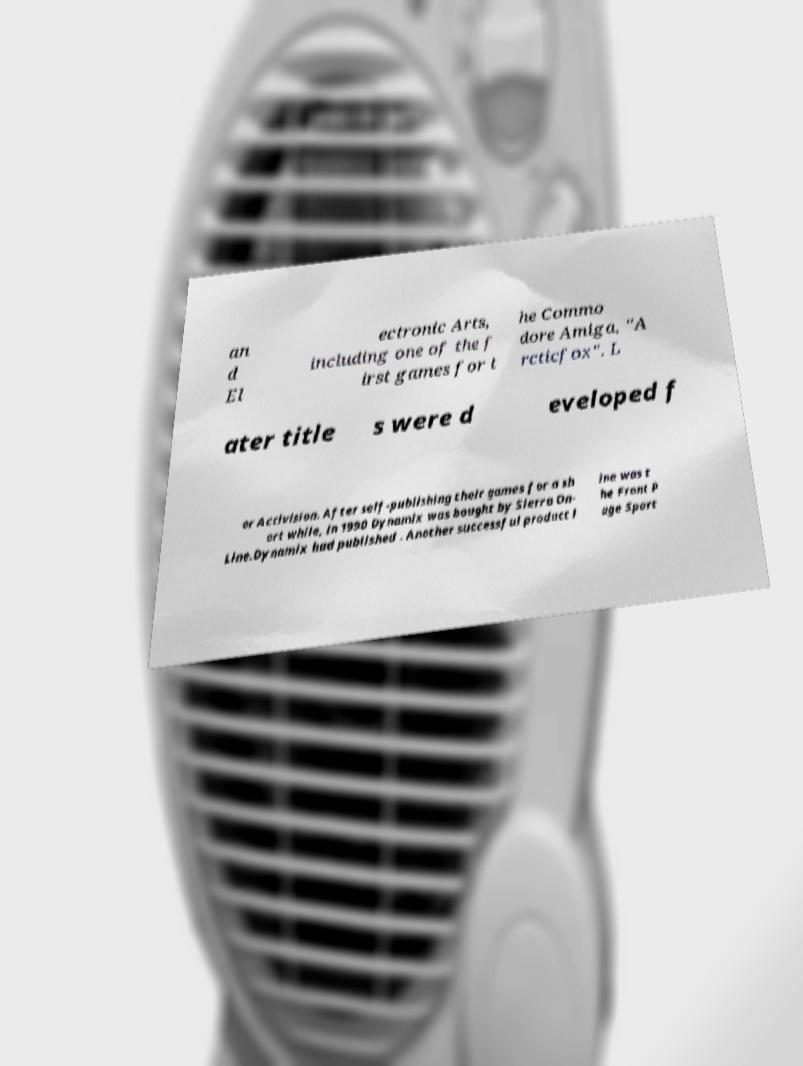Could you assist in decoding the text presented in this image and type it out clearly? an d El ectronic Arts, including one of the f irst games for t he Commo dore Amiga, "A rcticfox". L ater title s were d eveloped f or Activision. After self-publishing their games for a sh ort while, in 1990 Dynamix was bought by Sierra On- Line.Dynamix had published . Another successful product l ine was t he Front P age Sport 